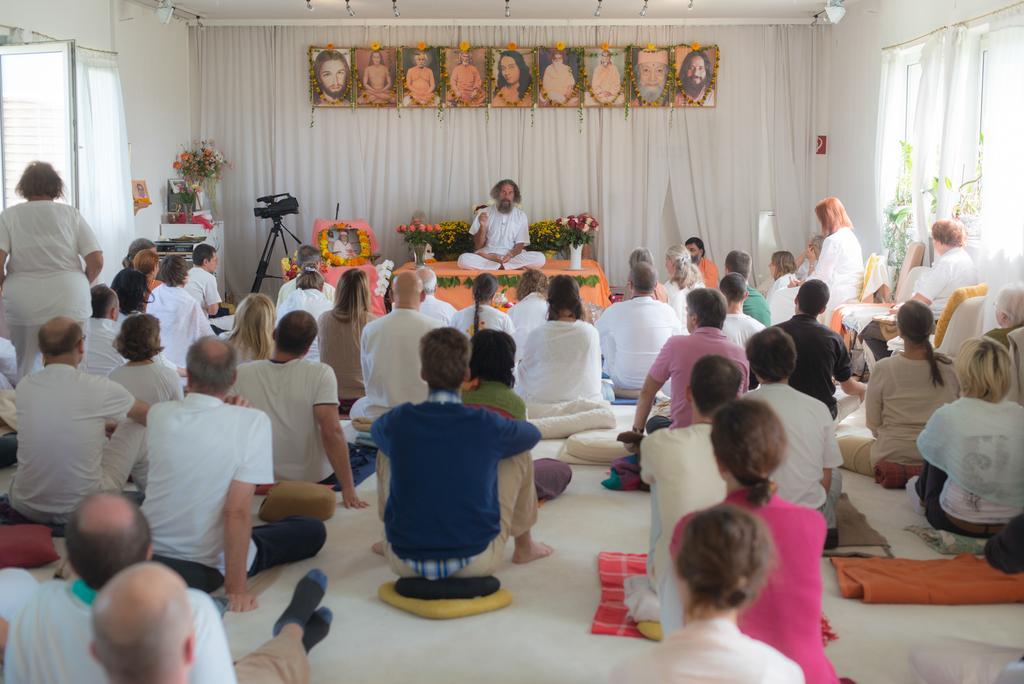In one or two sentences, can you explain what this image depicts? In this image we can see a few people sitting on the floor and a few people sitting on the chairs. And the other person sitting on the table and there are flowers, boxes and few objects. At the top we can see the curtains and photo frames attached to the wall. There is a photo frame on the table. And there are windows and lights. 